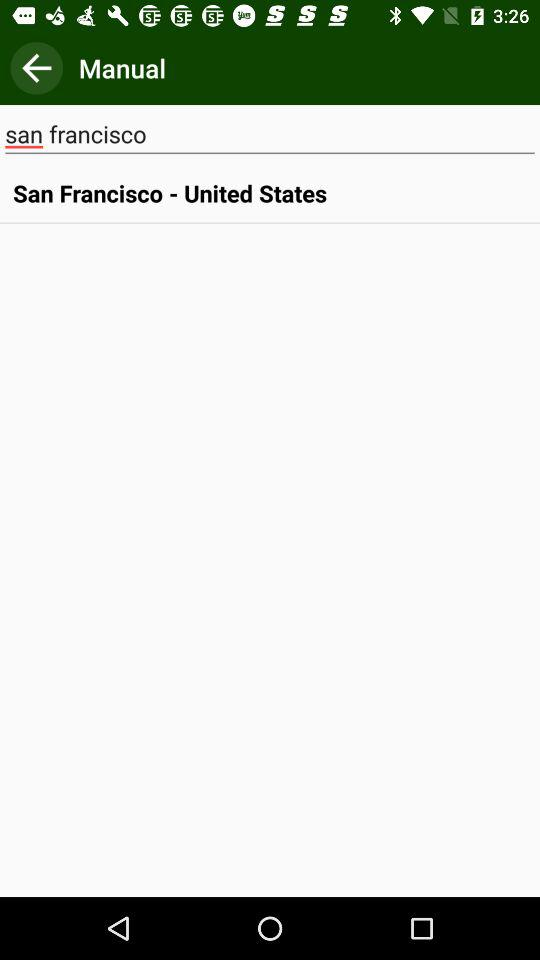What is the selected country? The selected country is the "United States". 